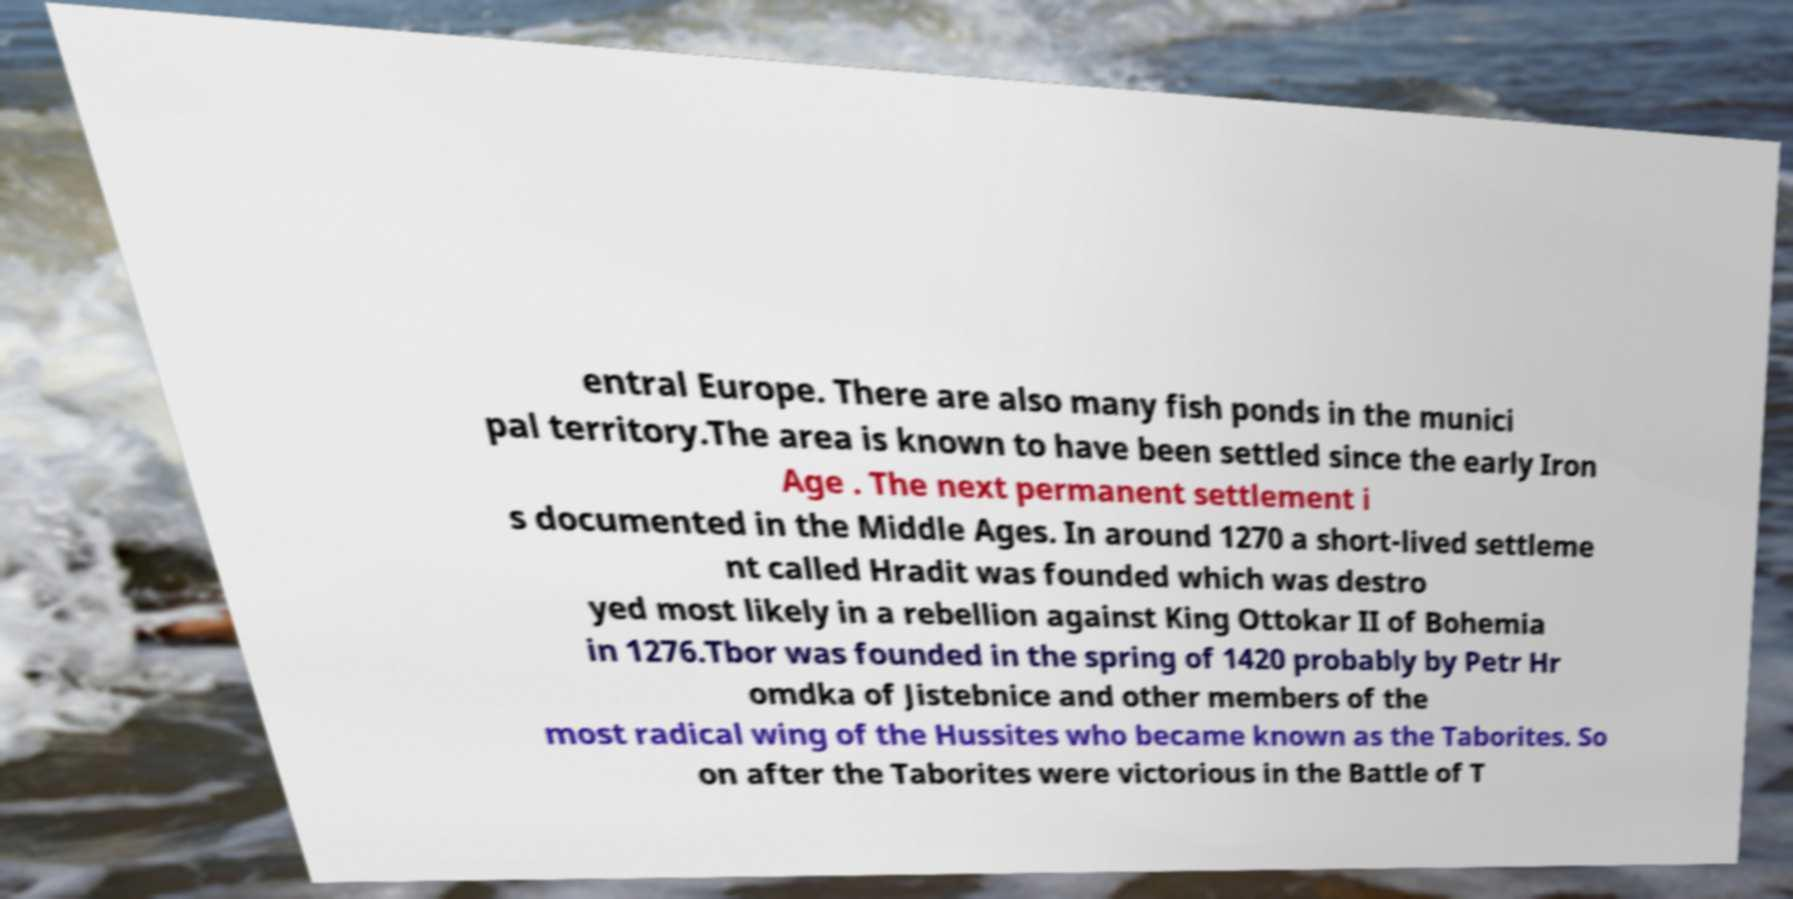What messages or text are displayed in this image? I need them in a readable, typed format. entral Europe. There are also many fish ponds in the munici pal territory.The area is known to have been settled since the early Iron Age . The next permanent settlement i s documented in the Middle Ages. In around 1270 a short-lived settleme nt called Hradit was founded which was destro yed most likely in a rebellion against King Ottokar II of Bohemia in 1276.Tbor was founded in the spring of 1420 probably by Petr Hr omdka of Jistebnice and other members of the most radical wing of the Hussites who became known as the Taborites. So on after the Taborites were victorious in the Battle of T 